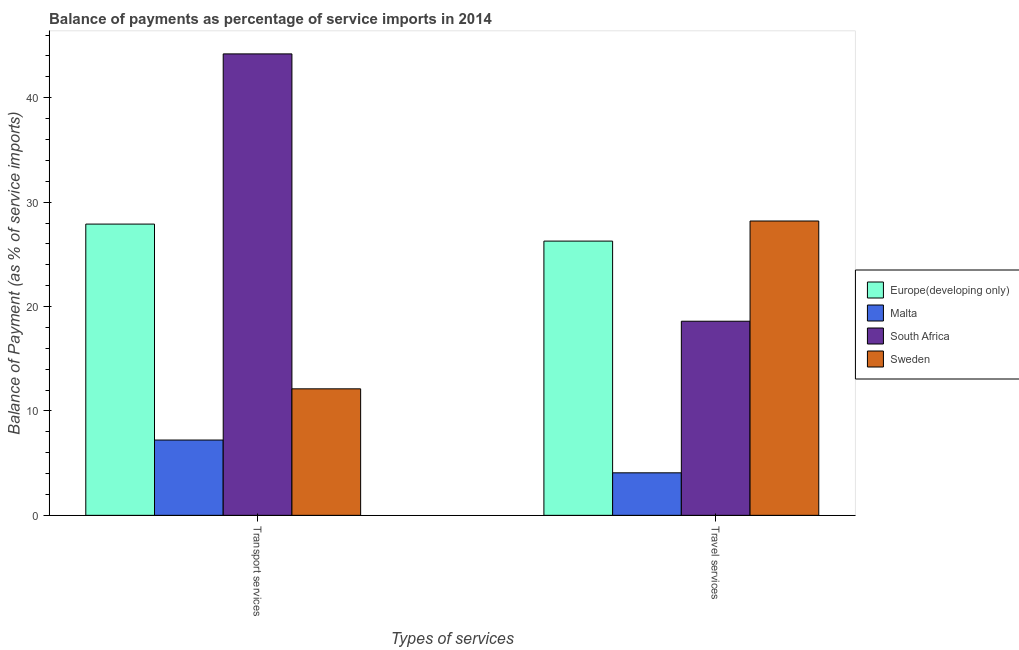How many groups of bars are there?
Your answer should be compact. 2. Are the number of bars per tick equal to the number of legend labels?
Your response must be concise. Yes. How many bars are there on the 1st tick from the left?
Keep it short and to the point. 4. What is the label of the 2nd group of bars from the left?
Your answer should be very brief. Travel services. What is the balance of payments of transport services in South Africa?
Ensure brevity in your answer.  44.2. Across all countries, what is the maximum balance of payments of travel services?
Give a very brief answer. 28.19. Across all countries, what is the minimum balance of payments of travel services?
Make the answer very short. 4.07. In which country was the balance of payments of transport services maximum?
Your answer should be compact. South Africa. In which country was the balance of payments of travel services minimum?
Offer a very short reply. Malta. What is the total balance of payments of travel services in the graph?
Provide a succinct answer. 77.13. What is the difference between the balance of payments of transport services in South Africa and that in Malta?
Offer a terse response. 36.99. What is the difference between the balance of payments of travel services in Malta and the balance of payments of transport services in Sweden?
Make the answer very short. -8.04. What is the average balance of payments of transport services per country?
Offer a very short reply. 22.86. What is the difference between the balance of payments of transport services and balance of payments of travel services in Europe(developing only)?
Make the answer very short. 1.63. In how many countries, is the balance of payments of transport services greater than 20 %?
Keep it short and to the point. 2. What is the ratio of the balance of payments of transport services in Malta to that in South Africa?
Your response must be concise. 0.16. What does the 3rd bar from the right in Travel services represents?
Your answer should be compact. Malta. How many bars are there?
Offer a very short reply. 8. How many countries are there in the graph?
Your response must be concise. 4. Are the values on the major ticks of Y-axis written in scientific E-notation?
Your answer should be compact. No. Does the graph contain any zero values?
Ensure brevity in your answer.  No. How many legend labels are there?
Make the answer very short. 4. What is the title of the graph?
Your response must be concise. Balance of payments as percentage of service imports in 2014. Does "Tajikistan" appear as one of the legend labels in the graph?
Keep it short and to the point. No. What is the label or title of the X-axis?
Ensure brevity in your answer.  Types of services. What is the label or title of the Y-axis?
Your answer should be very brief. Balance of Payment (as % of service imports). What is the Balance of Payment (as % of service imports) of Europe(developing only) in Transport services?
Ensure brevity in your answer.  27.9. What is the Balance of Payment (as % of service imports) of Malta in Transport services?
Your answer should be compact. 7.21. What is the Balance of Payment (as % of service imports) in South Africa in Transport services?
Your answer should be compact. 44.2. What is the Balance of Payment (as % of service imports) in Sweden in Transport services?
Your response must be concise. 12.12. What is the Balance of Payment (as % of service imports) of Europe(developing only) in Travel services?
Keep it short and to the point. 26.27. What is the Balance of Payment (as % of service imports) of Malta in Travel services?
Your response must be concise. 4.07. What is the Balance of Payment (as % of service imports) in South Africa in Travel services?
Ensure brevity in your answer.  18.59. What is the Balance of Payment (as % of service imports) in Sweden in Travel services?
Your answer should be very brief. 28.19. Across all Types of services, what is the maximum Balance of Payment (as % of service imports) of Europe(developing only)?
Ensure brevity in your answer.  27.9. Across all Types of services, what is the maximum Balance of Payment (as % of service imports) in Malta?
Offer a very short reply. 7.21. Across all Types of services, what is the maximum Balance of Payment (as % of service imports) in South Africa?
Make the answer very short. 44.2. Across all Types of services, what is the maximum Balance of Payment (as % of service imports) of Sweden?
Provide a short and direct response. 28.19. Across all Types of services, what is the minimum Balance of Payment (as % of service imports) in Europe(developing only)?
Make the answer very short. 26.27. Across all Types of services, what is the minimum Balance of Payment (as % of service imports) in Malta?
Your response must be concise. 4.07. Across all Types of services, what is the minimum Balance of Payment (as % of service imports) of South Africa?
Ensure brevity in your answer.  18.59. Across all Types of services, what is the minimum Balance of Payment (as % of service imports) in Sweden?
Your answer should be compact. 12.12. What is the total Balance of Payment (as % of service imports) of Europe(developing only) in the graph?
Give a very brief answer. 54.17. What is the total Balance of Payment (as % of service imports) in Malta in the graph?
Keep it short and to the point. 11.29. What is the total Balance of Payment (as % of service imports) of South Africa in the graph?
Provide a succinct answer. 62.79. What is the total Balance of Payment (as % of service imports) of Sweden in the graph?
Provide a succinct answer. 40.31. What is the difference between the Balance of Payment (as % of service imports) of Europe(developing only) in Transport services and that in Travel services?
Provide a short and direct response. 1.63. What is the difference between the Balance of Payment (as % of service imports) of Malta in Transport services and that in Travel services?
Give a very brief answer. 3.14. What is the difference between the Balance of Payment (as % of service imports) of South Africa in Transport services and that in Travel services?
Make the answer very short. 25.61. What is the difference between the Balance of Payment (as % of service imports) of Sweden in Transport services and that in Travel services?
Provide a short and direct response. -16.08. What is the difference between the Balance of Payment (as % of service imports) of Europe(developing only) in Transport services and the Balance of Payment (as % of service imports) of Malta in Travel services?
Keep it short and to the point. 23.82. What is the difference between the Balance of Payment (as % of service imports) of Europe(developing only) in Transport services and the Balance of Payment (as % of service imports) of South Africa in Travel services?
Provide a succinct answer. 9.3. What is the difference between the Balance of Payment (as % of service imports) in Europe(developing only) in Transport services and the Balance of Payment (as % of service imports) in Sweden in Travel services?
Provide a succinct answer. -0.29. What is the difference between the Balance of Payment (as % of service imports) in Malta in Transport services and the Balance of Payment (as % of service imports) in South Africa in Travel services?
Your answer should be compact. -11.38. What is the difference between the Balance of Payment (as % of service imports) of Malta in Transport services and the Balance of Payment (as % of service imports) of Sweden in Travel services?
Ensure brevity in your answer.  -20.98. What is the difference between the Balance of Payment (as % of service imports) of South Africa in Transport services and the Balance of Payment (as % of service imports) of Sweden in Travel services?
Provide a short and direct response. 16.01. What is the average Balance of Payment (as % of service imports) in Europe(developing only) per Types of services?
Your response must be concise. 27.08. What is the average Balance of Payment (as % of service imports) in Malta per Types of services?
Provide a short and direct response. 5.64. What is the average Balance of Payment (as % of service imports) of South Africa per Types of services?
Your answer should be compact. 31.4. What is the average Balance of Payment (as % of service imports) of Sweden per Types of services?
Your answer should be compact. 20.15. What is the difference between the Balance of Payment (as % of service imports) in Europe(developing only) and Balance of Payment (as % of service imports) in Malta in Transport services?
Offer a terse response. 20.68. What is the difference between the Balance of Payment (as % of service imports) of Europe(developing only) and Balance of Payment (as % of service imports) of South Africa in Transport services?
Provide a short and direct response. -16.3. What is the difference between the Balance of Payment (as % of service imports) of Europe(developing only) and Balance of Payment (as % of service imports) of Sweden in Transport services?
Provide a succinct answer. 15.78. What is the difference between the Balance of Payment (as % of service imports) of Malta and Balance of Payment (as % of service imports) of South Africa in Transport services?
Make the answer very short. -36.99. What is the difference between the Balance of Payment (as % of service imports) in Malta and Balance of Payment (as % of service imports) in Sweden in Transport services?
Offer a terse response. -4.9. What is the difference between the Balance of Payment (as % of service imports) of South Africa and Balance of Payment (as % of service imports) of Sweden in Transport services?
Make the answer very short. 32.08. What is the difference between the Balance of Payment (as % of service imports) of Europe(developing only) and Balance of Payment (as % of service imports) of Malta in Travel services?
Your answer should be compact. 22.2. What is the difference between the Balance of Payment (as % of service imports) of Europe(developing only) and Balance of Payment (as % of service imports) of South Africa in Travel services?
Your answer should be very brief. 7.67. What is the difference between the Balance of Payment (as % of service imports) of Europe(developing only) and Balance of Payment (as % of service imports) of Sweden in Travel services?
Your answer should be very brief. -1.92. What is the difference between the Balance of Payment (as % of service imports) of Malta and Balance of Payment (as % of service imports) of South Africa in Travel services?
Offer a terse response. -14.52. What is the difference between the Balance of Payment (as % of service imports) in Malta and Balance of Payment (as % of service imports) in Sweden in Travel services?
Your answer should be very brief. -24.12. What is the difference between the Balance of Payment (as % of service imports) of South Africa and Balance of Payment (as % of service imports) of Sweden in Travel services?
Give a very brief answer. -9.6. What is the ratio of the Balance of Payment (as % of service imports) of Europe(developing only) in Transport services to that in Travel services?
Offer a very short reply. 1.06. What is the ratio of the Balance of Payment (as % of service imports) of Malta in Transport services to that in Travel services?
Offer a terse response. 1.77. What is the ratio of the Balance of Payment (as % of service imports) of South Africa in Transport services to that in Travel services?
Your response must be concise. 2.38. What is the ratio of the Balance of Payment (as % of service imports) in Sweden in Transport services to that in Travel services?
Your response must be concise. 0.43. What is the difference between the highest and the second highest Balance of Payment (as % of service imports) in Europe(developing only)?
Your answer should be compact. 1.63. What is the difference between the highest and the second highest Balance of Payment (as % of service imports) of Malta?
Give a very brief answer. 3.14. What is the difference between the highest and the second highest Balance of Payment (as % of service imports) in South Africa?
Offer a terse response. 25.61. What is the difference between the highest and the second highest Balance of Payment (as % of service imports) of Sweden?
Ensure brevity in your answer.  16.08. What is the difference between the highest and the lowest Balance of Payment (as % of service imports) of Europe(developing only)?
Your response must be concise. 1.63. What is the difference between the highest and the lowest Balance of Payment (as % of service imports) of Malta?
Provide a succinct answer. 3.14. What is the difference between the highest and the lowest Balance of Payment (as % of service imports) of South Africa?
Your answer should be compact. 25.61. What is the difference between the highest and the lowest Balance of Payment (as % of service imports) of Sweden?
Provide a succinct answer. 16.08. 